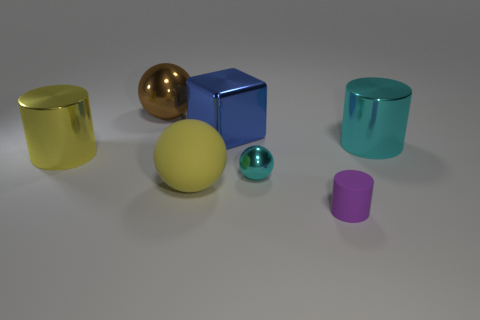Is the number of brown shiny things greater than the number of large gray blocks?
Your answer should be compact. Yes. Do the object in front of the rubber sphere and the cyan object in front of the big cyan shiny object have the same size?
Ensure brevity in your answer.  Yes. What number of matte objects are both on the right side of the yellow sphere and behind the tiny purple rubber cylinder?
Provide a short and direct response. 0. There is another large rubber thing that is the same shape as the large brown thing; what is its color?
Give a very brief answer. Yellow. Are there fewer large balls than small cyan balls?
Your response must be concise. No. There is a blue shiny block; does it have the same size as the matte object on the left side of the small cyan shiny sphere?
Provide a succinct answer. Yes. What color is the shiny sphere that is on the left side of the metallic sphere to the right of the brown metallic ball?
Provide a short and direct response. Brown. What number of objects are metal cylinders that are on the right side of the tiny purple rubber thing or spheres that are in front of the blue object?
Make the answer very short. 3. Is the blue metallic block the same size as the brown metal thing?
Keep it short and to the point. Yes. Is the shape of the matte thing right of the shiny cube the same as the big yellow thing behind the big matte ball?
Make the answer very short. Yes. 